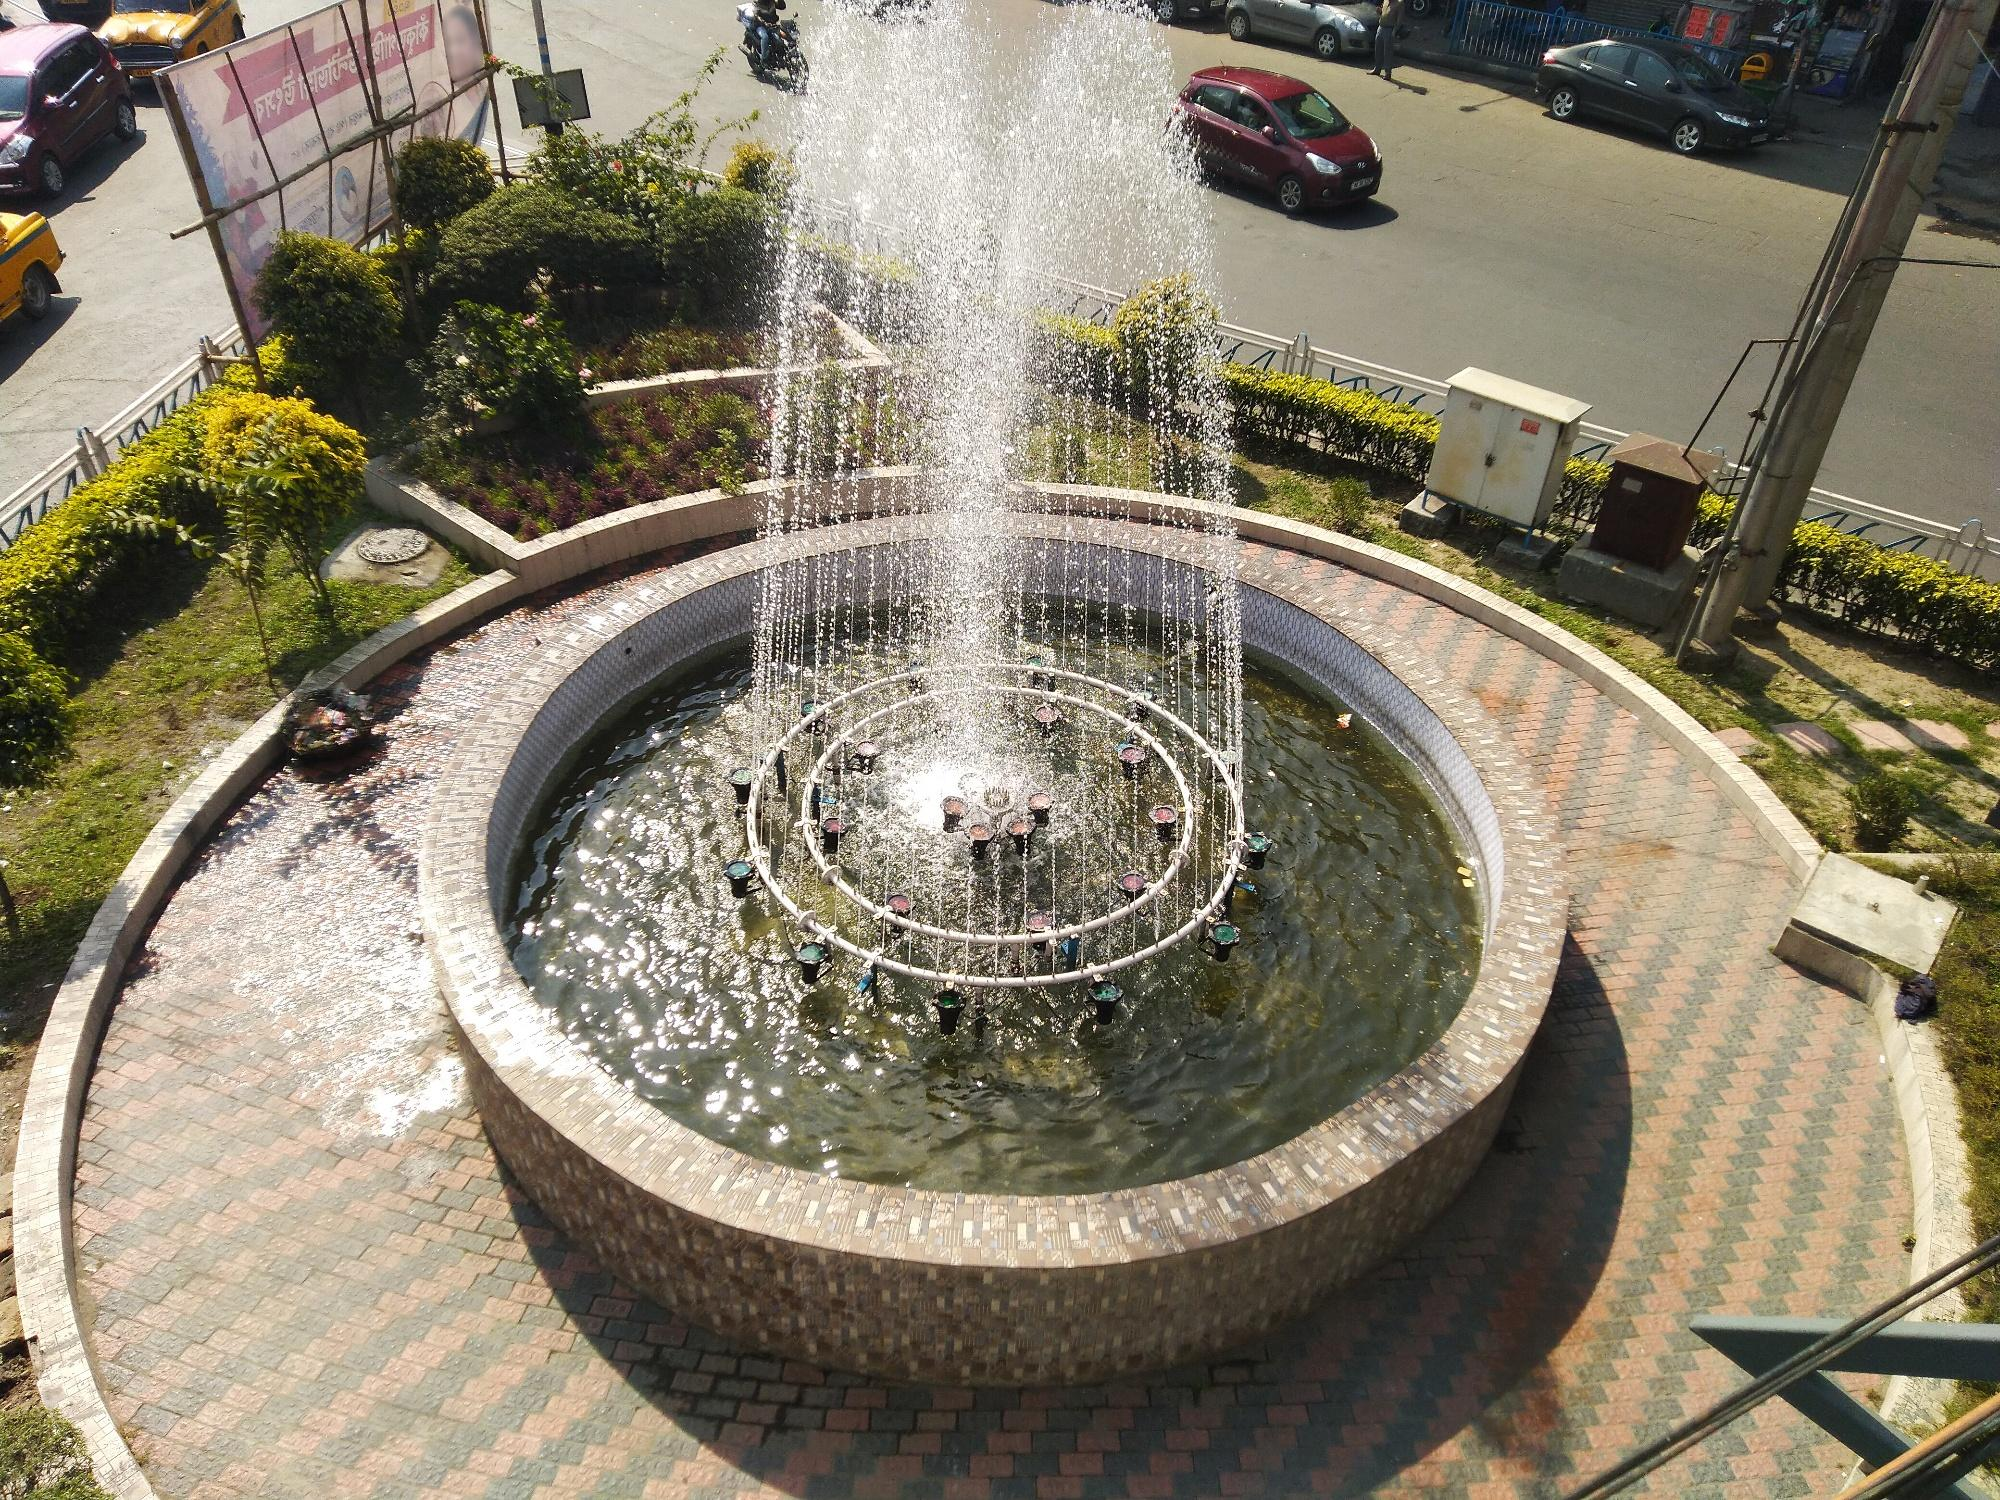Given the fountain's design and location, describe an event that could be held here. An ideal event for this setting would be a community festival celebrating local culture. The fountain at the heart of the roundabout could serve as a central stage, with performances from local musicians and artists. Food stalls and artisans could line the brick walkway, while the lush greenery provides a refreshing backdrop for visitors to socialize and enjoy the festivities. At night, colorful lights could illuminate the fountain's water jets, creating a dazzling spectacle. 